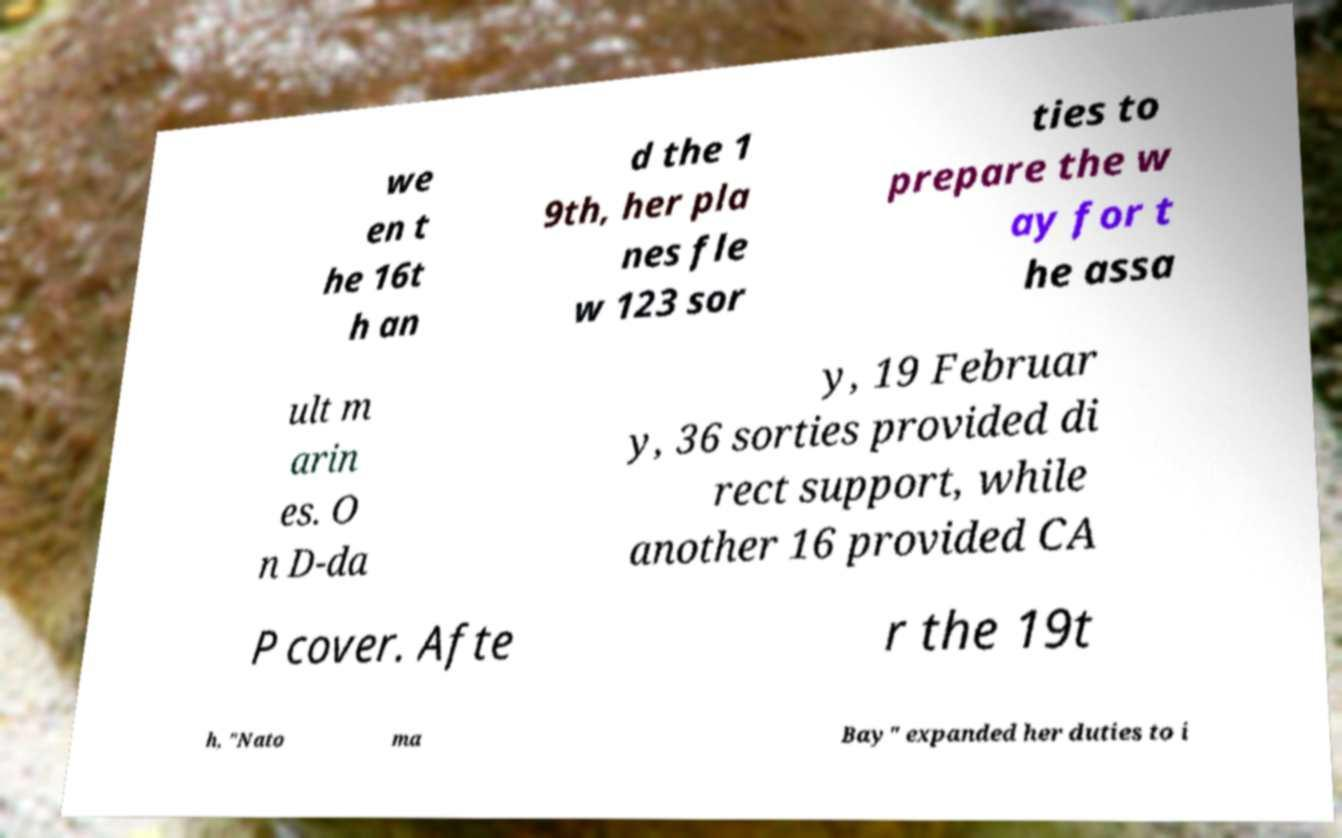Please read and relay the text visible in this image. What does it say? we en t he 16t h an d the 1 9th, her pla nes fle w 123 sor ties to prepare the w ay for t he assa ult m arin es. O n D-da y, 19 Februar y, 36 sorties provided di rect support, while another 16 provided CA P cover. Afte r the 19t h, "Nato ma Bay" expanded her duties to i 